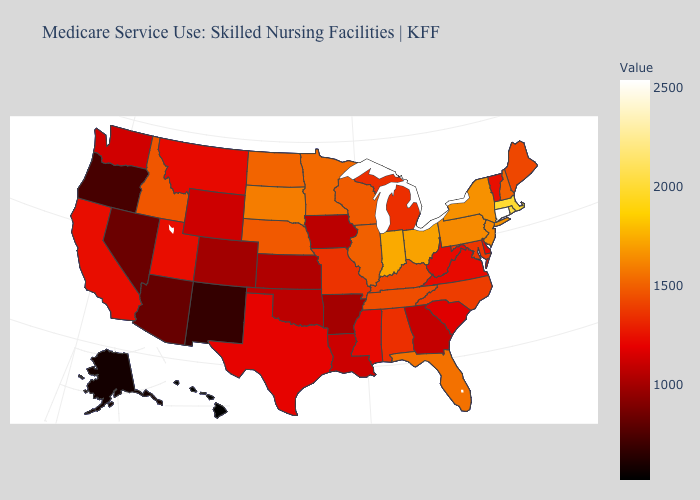Which states have the lowest value in the USA?
Concise answer only. Hawaii. Does Virginia have a lower value than Indiana?
Give a very brief answer. Yes. Among the states that border Oregon , does Nevada have the highest value?
Keep it brief. No. Among the states that border Ohio , which have the highest value?
Be succinct. Indiana. Does Hawaii have the lowest value in the USA?
Write a very short answer. Yes. Does the map have missing data?
Short answer required. No. Does the map have missing data?
Answer briefly. No. 